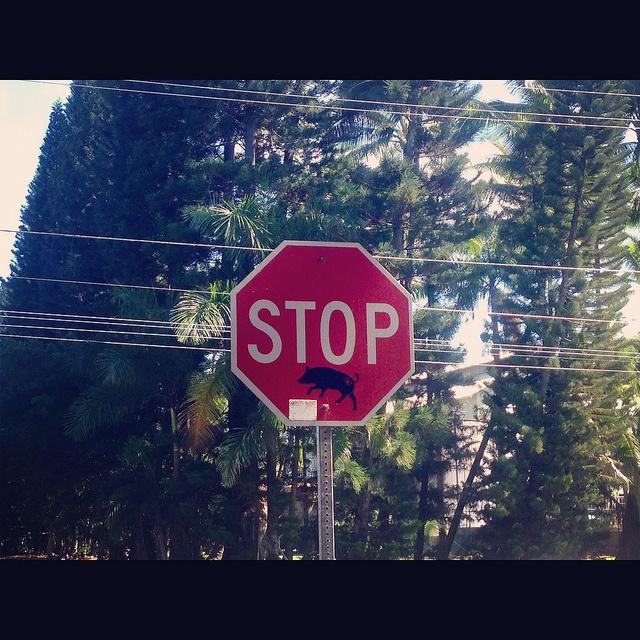Describe the objects in this image and their specific colors. I can see a stop sign in black, purple, and darkgray tones in this image. 